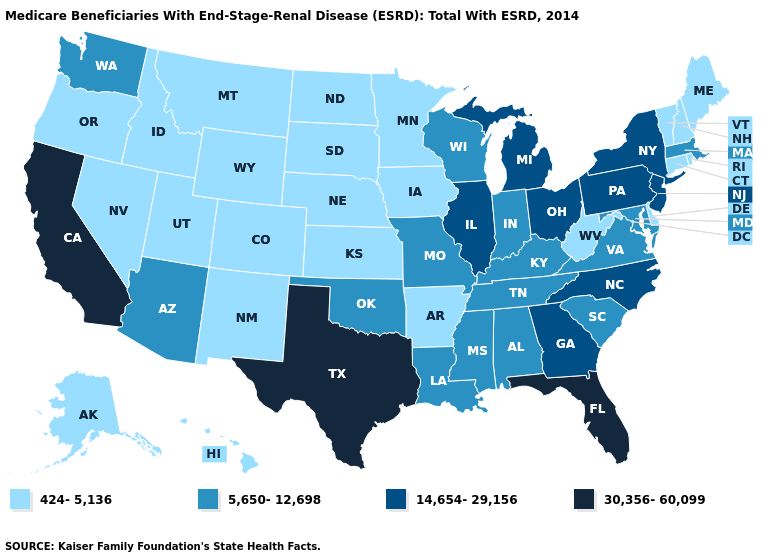What is the value of Virginia?
Quick response, please. 5,650-12,698. What is the value of New Jersey?
Write a very short answer. 14,654-29,156. Among the states that border Georgia , which have the lowest value?
Give a very brief answer. Alabama, South Carolina, Tennessee. Does California have the highest value in the USA?
Quick response, please. Yes. Name the states that have a value in the range 424-5,136?
Concise answer only. Alaska, Arkansas, Colorado, Connecticut, Delaware, Hawaii, Idaho, Iowa, Kansas, Maine, Minnesota, Montana, Nebraska, Nevada, New Hampshire, New Mexico, North Dakota, Oregon, Rhode Island, South Dakota, Utah, Vermont, West Virginia, Wyoming. Does the first symbol in the legend represent the smallest category?
Write a very short answer. Yes. Name the states that have a value in the range 14,654-29,156?
Short answer required. Georgia, Illinois, Michigan, New Jersey, New York, North Carolina, Ohio, Pennsylvania. Name the states that have a value in the range 5,650-12,698?
Short answer required. Alabama, Arizona, Indiana, Kentucky, Louisiana, Maryland, Massachusetts, Mississippi, Missouri, Oklahoma, South Carolina, Tennessee, Virginia, Washington, Wisconsin. Does Pennsylvania have the highest value in the Northeast?
Short answer required. Yes. Name the states that have a value in the range 30,356-60,099?
Keep it brief. California, Florida, Texas. Which states have the highest value in the USA?
Give a very brief answer. California, Florida, Texas. Which states have the lowest value in the USA?
Give a very brief answer. Alaska, Arkansas, Colorado, Connecticut, Delaware, Hawaii, Idaho, Iowa, Kansas, Maine, Minnesota, Montana, Nebraska, Nevada, New Hampshire, New Mexico, North Dakota, Oregon, Rhode Island, South Dakota, Utah, Vermont, West Virginia, Wyoming. Does Ohio have the highest value in the MidWest?
Be succinct. Yes. Does Maryland have the highest value in the USA?
Be succinct. No. Does Alabama have the lowest value in the USA?
Quick response, please. No. 